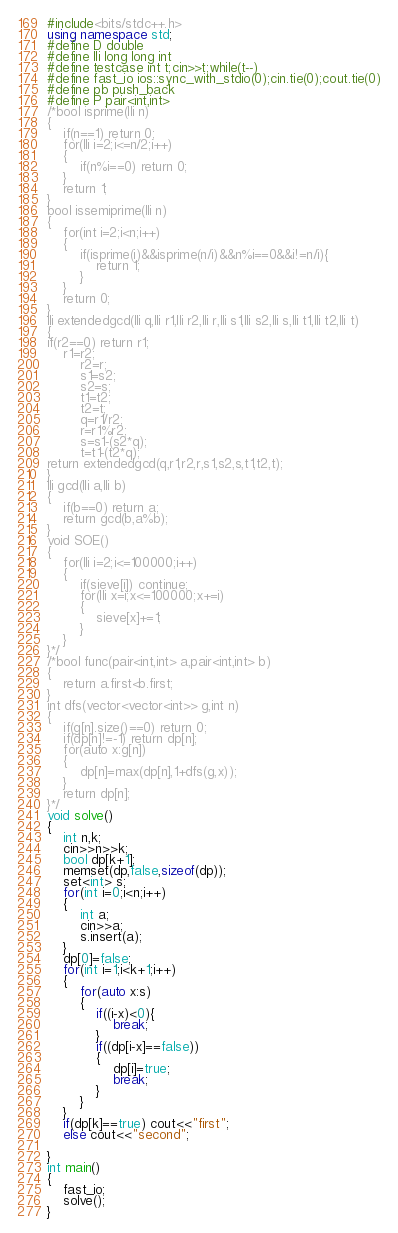<code> <loc_0><loc_0><loc_500><loc_500><_C++_>#include<bits/stdc++.h>
using namespace std;
#define D double
#define lli long long int
#define testcase int t;cin>>t;while(t--)
#define fast_io ios::sync_with_stdio(0);cin.tie(0);cout.tie(0)
#define pb push_back
#define P pair<int,int>
/*bool isprime(lli n)
{
    if(n==1) return 0;
    for(lli i=2;i<=n/2;i++)
    {
        if(n%i==0) return 0;
    }
    return 1;
}
bool issemiprime(lli n)
{
    for(int i=2;i<n;i++)
    {
        if(isprime(i)&&isprime(n/i)&&n%i==0&&i!=n/i){
            return 1;
        }
    }
    return 0;
}
lli extendedgcd(lli q,lli r1,lli r2,lli r,lli s1,lli s2,lli s,lli t1,lli t2,lli t)
{
if(r2==0) return r1;
	r1=r2;
        r2=r;
        s1=s2;
        s2=s;
        t1=t2;
        t2=t;
        q=r1/r2;
        r=r1%r2;
        s=s1-(s2*q);
        t=t1-(t2*q);
return extendedgcd(q,r1,r2,r,s1,s2,s,t1,t2,t);
}
lli gcd(lli a,lli b)
{
    if(b==0) return a;
    return gcd(b,a%b);
}
void SOE()
{
    for(lli i=2;i<=100000;i++)
    {
        if(sieve[i]) continue;
        for(lli x=i;x<=100000;x+=i)
        {
            sieve[x]+=1;
        }
    }
}*/
/*bool func(pair<int,int> a,pair<int,int> b)
{
    return a.first<b.first;
}
int dfs(vector<vector<int>> g,int n)
{
    if(g[n].size()==0) return 0;
    if(dp[n]!=-1) return dp[n];
    for(auto x:g[n])
    {
        dp[n]=max(dp[n],1+dfs(g,x));
    }
    return dp[n];
}*/
void solve()
{
    int n,k;
    cin>>n>>k;
    bool dp[k+1];
    memset(dp,false,sizeof(dp));
    set<int> s;
    for(int i=0;i<n;i++)
    {
        int a;
        cin>>a;
        s.insert(a);
    }
    dp[0]=false;
    for(int i=1;i<k+1;i++)
    {
        for(auto x:s)
        {
            if((i-x)<0){
                break;
            }
            if((dp[i-x]==false))
            {
                dp[i]=true;
                break;
            }
        }
    }
    if(dp[k]==true) cout<<"first";
    else cout<<"second";

}
int main()
{
    fast_io;
    solve();
}
</code> 